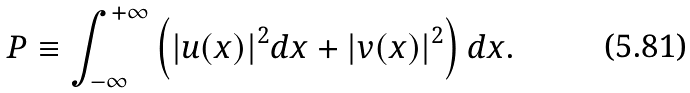<formula> <loc_0><loc_0><loc_500><loc_500>P \equiv \int _ { - \infty } ^ { + \infty } \left ( | u ( x ) | ^ { 2 } d x + | v ( x ) | ^ { 2 } \right ) d x .</formula> 